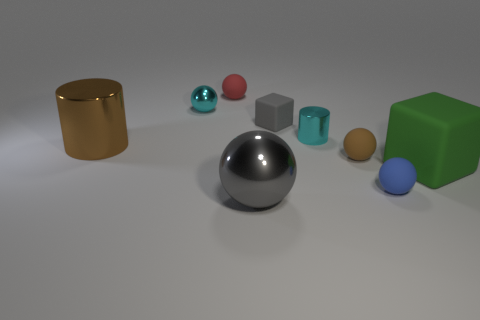There is a tiny red thing that is made of the same material as the blue object; what is its shape?
Give a very brief answer. Sphere. There is a matte block behind the green object; is it the same size as the gray metallic sphere?
Make the answer very short. No. What is the shape of the metal thing right of the matte cube behind the big matte object?
Offer a terse response. Cylinder. What is the size of the rubber ball in front of the big thing that is right of the gray matte cube?
Your answer should be very brief. Small. What color is the big shiny thing that is in front of the small blue ball?
Your answer should be compact. Gray. The brown object that is made of the same material as the big gray sphere is what size?
Give a very brief answer. Large. How many tiny brown rubber things are the same shape as the green rubber thing?
Your response must be concise. 0. What material is the cylinder that is the same size as the cyan ball?
Keep it short and to the point. Metal. Is there a large brown ball that has the same material as the small red thing?
Offer a terse response. No. What color is the sphere that is on the left side of the tiny gray object and in front of the brown shiny thing?
Your answer should be compact. Gray. 